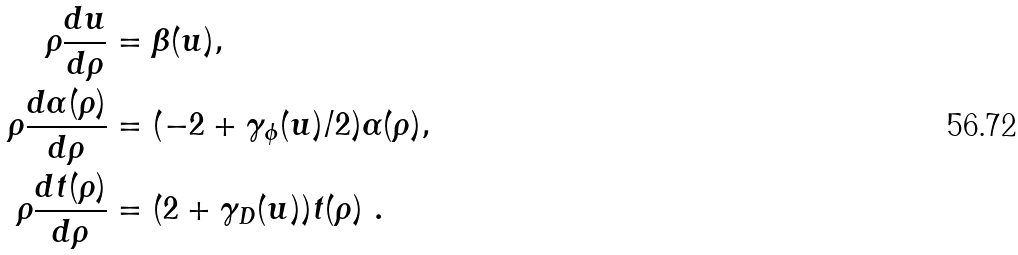Convert formula to latex. <formula><loc_0><loc_0><loc_500><loc_500>\rho \frac { d u } { d \rho } & = \beta ( u ) , \\ \rho \frac { d \alpha ( \rho ) } { d \rho } & = ( - 2 + \gamma _ { \phi } ( u ) / 2 ) \alpha ( \rho ) , \\ \rho \frac { d t ( \rho ) } { d \rho } & = ( 2 + \gamma _ { D } ( u ) ) t ( \rho ) \ .</formula> 